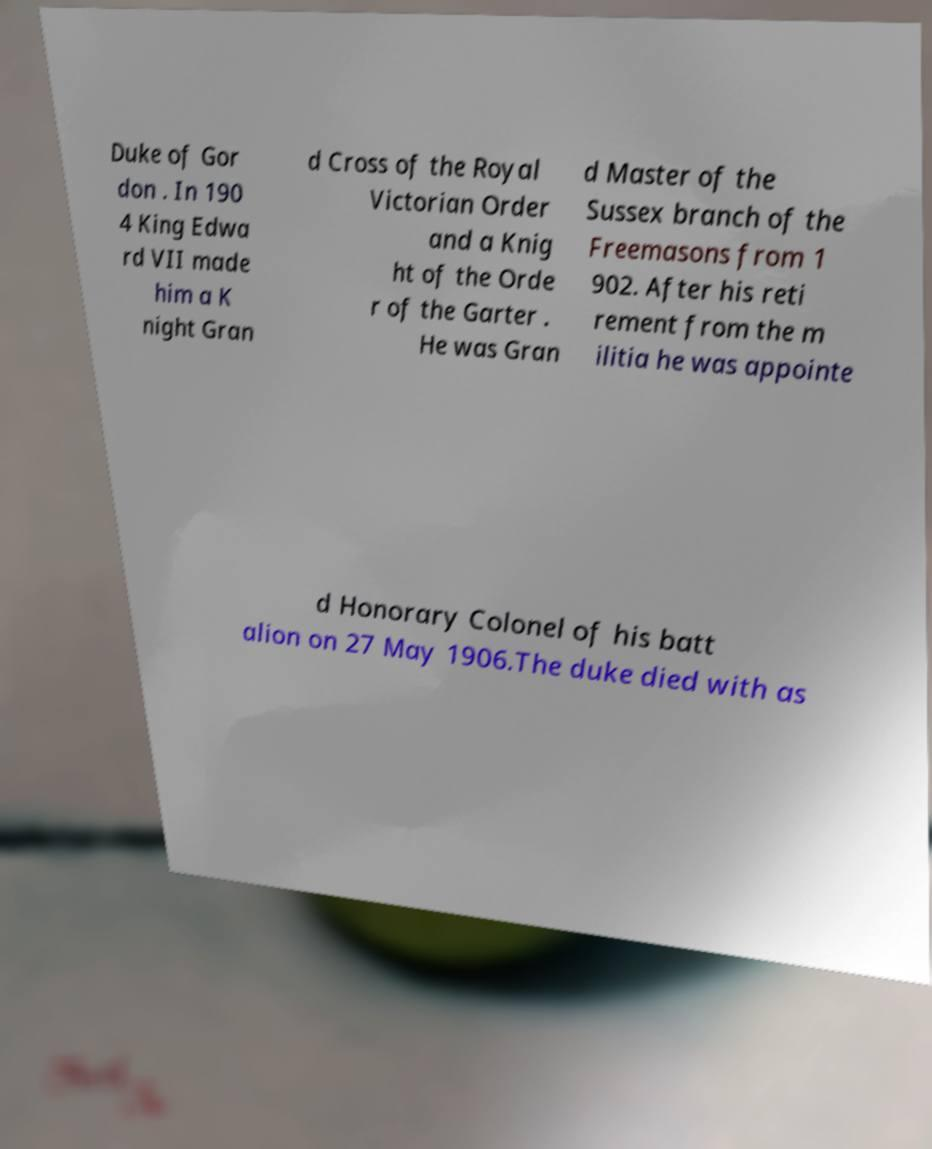Can you read and provide the text displayed in the image?This photo seems to have some interesting text. Can you extract and type it out for me? Duke of Gor don . In 190 4 King Edwa rd VII made him a K night Gran d Cross of the Royal Victorian Order and a Knig ht of the Orde r of the Garter . He was Gran d Master of the Sussex branch of the Freemasons from 1 902. After his reti rement from the m ilitia he was appointe d Honorary Colonel of his batt alion on 27 May 1906.The duke died with as 